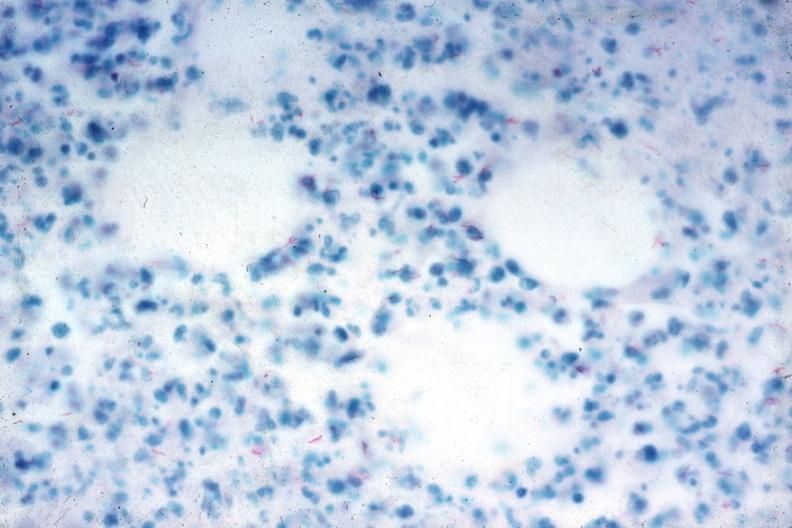s abdomen present?
Answer the question using a single word or phrase. Yes 